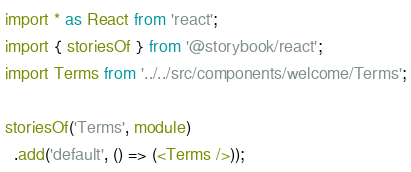Convert code to text. <code><loc_0><loc_0><loc_500><loc_500><_TypeScript_>import * as React from 'react';
import { storiesOf } from '@storybook/react';
import Terms from '../../src/components/welcome/Terms';

storiesOf('Terms', module)
  .add('default', () => (<Terms />));</code> 